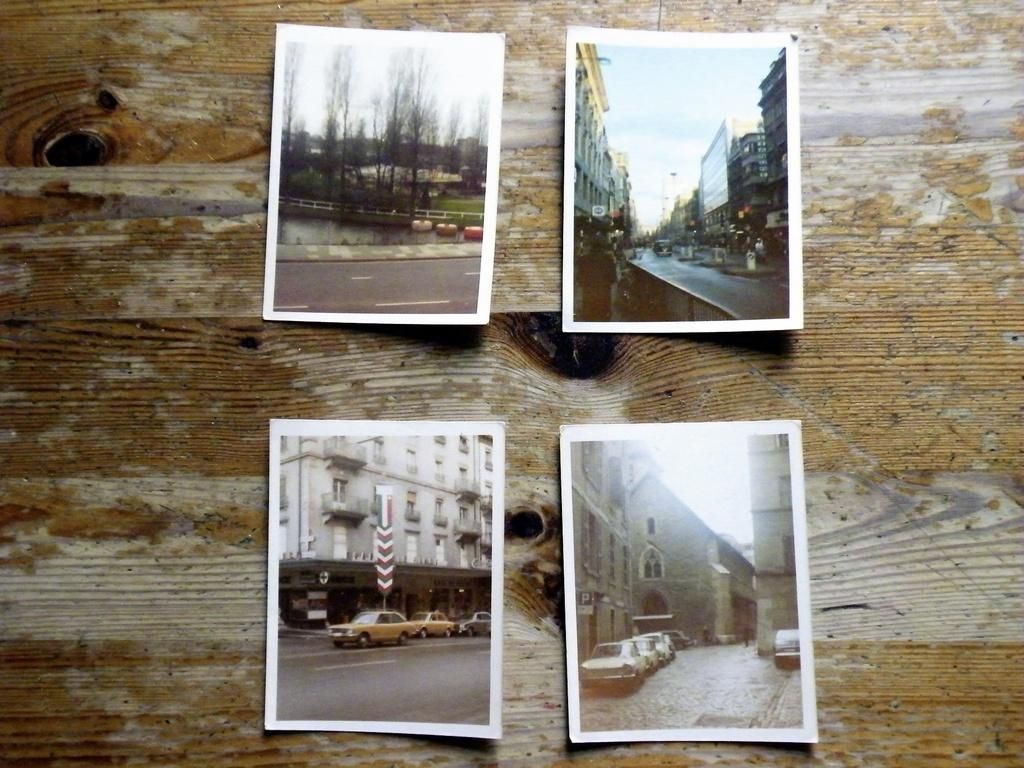What is the main feature in the center of the image? There is a wooden wall in the center of the image. What is displayed on the wooden wall? The wooden wall has a collection of photos. What types of images can be seen in the photos? The photos contain images of the sky, buildings, trees, and vehicles. What type of copper material can be seen in the image? There is no copper material present in the image. Are there any shoes visible in the image? There are no shoes visible in the image. 